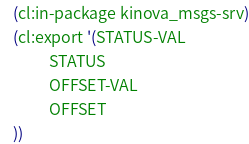Convert code to text. <code><loc_0><loc_0><loc_500><loc_500><_Lisp_>(cl:in-package kinova_msgs-srv)
(cl:export '(STATUS-VAL
          STATUS
          OFFSET-VAL
          OFFSET
))</code> 